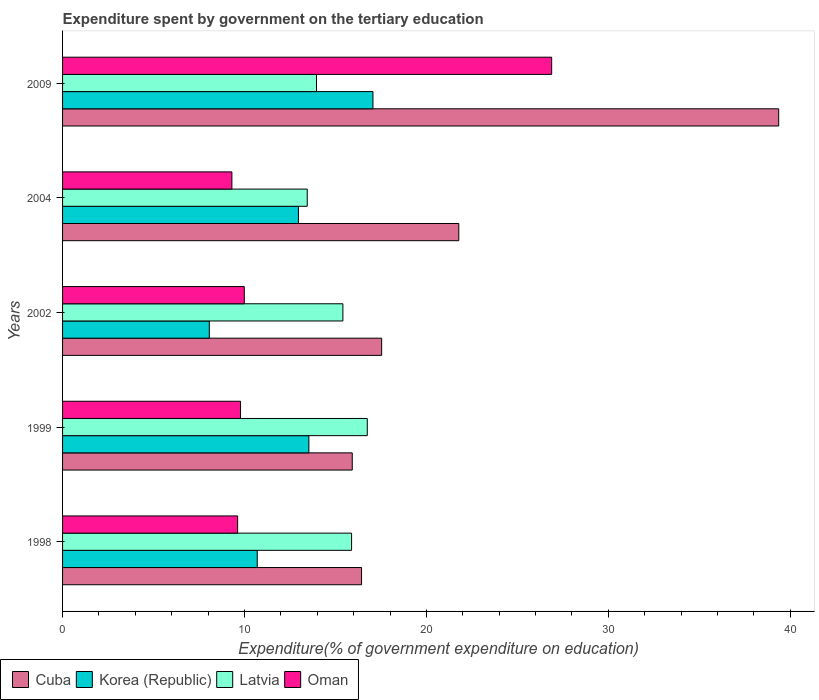How many different coloured bars are there?
Provide a short and direct response. 4. How many bars are there on the 2nd tick from the top?
Give a very brief answer. 4. How many bars are there on the 5th tick from the bottom?
Your answer should be very brief. 4. In how many cases, is the number of bars for a given year not equal to the number of legend labels?
Your response must be concise. 0. What is the expenditure spent by government on the tertiary education in Korea (Republic) in 1998?
Offer a terse response. 10.7. Across all years, what is the maximum expenditure spent by government on the tertiary education in Latvia?
Keep it short and to the point. 16.75. Across all years, what is the minimum expenditure spent by government on the tertiary education in Oman?
Offer a terse response. 9.31. In which year was the expenditure spent by government on the tertiary education in Oman maximum?
Provide a succinct answer. 2009. In which year was the expenditure spent by government on the tertiary education in Latvia minimum?
Give a very brief answer. 2004. What is the total expenditure spent by government on the tertiary education in Korea (Republic) in the graph?
Your answer should be compact. 62.33. What is the difference between the expenditure spent by government on the tertiary education in Latvia in 1998 and that in 2002?
Offer a very short reply. 0.48. What is the difference between the expenditure spent by government on the tertiary education in Oman in 2009 and the expenditure spent by government on the tertiary education in Latvia in 2002?
Ensure brevity in your answer.  11.48. What is the average expenditure spent by government on the tertiary education in Latvia per year?
Make the answer very short. 15.09. In the year 2002, what is the difference between the expenditure spent by government on the tertiary education in Cuba and expenditure spent by government on the tertiary education in Korea (Republic)?
Offer a very short reply. 9.47. What is the ratio of the expenditure spent by government on the tertiary education in Cuba in 1998 to that in 1999?
Provide a short and direct response. 1.03. Is the difference between the expenditure spent by government on the tertiary education in Cuba in 1998 and 2002 greater than the difference between the expenditure spent by government on the tertiary education in Korea (Republic) in 1998 and 2002?
Offer a very short reply. No. What is the difference between the highest and the second highest expenditure spent by government on the tertiary education in Cuba?
Your answer should be compact. 17.58. What is the difference between the highest and the lowest expenditure spent by government on the tertiary education in Korea (Republic)?
Provide a succinct answer. 8.99. Is it the case that in every year, the sum of the expenditure spent by government on the tertiary education in Cuba and expenditure spent by government on the tertiary education in Latvia is greater than the sum of expenditure spent by government on the tertiary education in Oman and expenditure spent by government on the tertiary education in Korea (Republic)?
Make the answer very short. Yes. What does the 4th bar from the top in 2002 represents?
Provide a succinct answer. Cuba. What does the 3rd bar from the bottom in 2002 represents?
Make the answer very short. Latvia. How many bars are there?
Offer a terse response. 20. How many years are there in the graph?
Ensure brevity in your answer.  5. Are the values on the major ticks of X-axis written in scientific E-notation?
Offer a terse response. No. Where does the legend appear in the graph?
Keep it short and to the point. Bottom left. How many legend labels are there?
Keep it short and to the point. 4. How are the legend labels stacked?
Offer a terse response. Horizontal. What is the title of the graph?
Ensure brevity in your answer.  Expenditure spent by government on the tertiary education. Does "Estonia" appear as one of the legend labels in the graph?
Offer a very short reply. No. What is the label or title of the X-axis?
Keep it short and to the point. Expenditure(% of government expenditure on education). What is the label or title of the Y-axis?
Ensure brevity in your answer.  Years. What is the Expenditure(% of government expenditure on education) of Cuba in 1998?
Ensure brevity in your answer.  16.43. What is the Expenditure(% of government expenditure on education) in Korea (Republic) in 1998?
Make the answer very short. 10.7. What is the Expenditure(% of government expenditure on education) in Latvia in 1998?
Your response must be concise. 15.89. What is the Expenditure(% of government expenditure on education) of Oman in 1998?
Your answer should be very brief. 9.62. What is the Expenditure(% of government expenditure on education) of Cuba in 1999?
Your answer should be very brief. 15.92. What is the Expenditure(% of government expenditure on education) of Korea (Republic) in 1999?
Your response must be concise. 13.54. What is the Expenditure(% of government expenditure on education) in Latvia in 1999?
Provide a succinct answer. 16.75. What is the Expenditure(% of government expenditure on education) of Oman in 1999?
Offer a very short reply. 9.78. What is the Expenditure(% of government expenditure on education) of Cuba in 2002?
Your answer should be very brief. 17.54. What is the Expenditure(% of government expenditure on education) of Korea (Republic) in 2002?
Your answer should be very brief. 8.07. What is the Expenditure(% of government expenditure on education) of Latvia in 2002?
Your answer should be compact. 15.41. What is the Expenditure(% of government expenditure on education) in Oman in 2002?
Make the answer very short. 9.99. What is the Expenditure(% of government expenditure on education) of Cuba in 2004?
Offer a very short reply. 21.78. What is the Expenditure(% of government expenditure on education) in Korea (Republic) in 2004?
Your answer should be very brief. 12.96. What is the Expenditure(% of government expenditure on education) in Latvia in 2004?
Provide a short and direct response. 13.45. What is the Expenditure(% of government expenditure on education) of Oman in 2004?
Your answer should be very brief. 9.31. What is the Expenditure(% of government expenditure on education) in Cuba in 2009?
Offer a very short reply. 39.36. What is the Expenditure(% of government expenditure on education) in Korea (Republic) in 2009?
Make the answer very short. 17.06. What is the Expenditure(% of government expenditure on education) of Latvia in 2009?
Give a very brief answer. 13.96. What is the Expenditure(% of government expenditure on education) in Oman in 2009?
Keep it short and to the point. 26.88. Across all years, what is the maximum Expenditure(% of government expenditure on education) of Cuba?
Ensure brevity in your answer.  39.36. Across all years, what is the maximum Expenditure(% of government expenditure on education) in Korea (Republic)?
Provide a succinct answer. 17.06. Across all years, what is the maximum Expenditure(% of government expenditure on education) of Latvia?
Give a very brief answer. 16.75. Across all years, what is the maximum Expenditure(% of government expenditure on education) of Oman?
Make the answer very short. 26.88. Across all years, what is the minimum Expenditure(% of government expenditure on education) of Cuba?
Offer a very short reply. 15.92. Across all years, what is the minimum Expenditure(% of government expenditure on education) of Korea (Republic)?
Make the answer very short. 8.07. Across all years, what is the minimum Expenditure(% of government expenditure on education) in Latvia?
Offer a very short reply. 13.45. Across all years, what is the minimum Expenditure(% of government expenditure on education) of Oman?
Your answer should be compact. 9.31. What is the total Expenditure(% of government expenditure on education) in Cuba in the graph?
Offer a very short reply. 111.03. What is the total Expenditure(% of government expenditure on education) of Korea (Republic) in the graph?
Ensure brevity in your answer.  62.33. What is the total Expenditure(% of government expenditure on education) in Latvia in the graph?
Offer a terse response. 75.45. What is the total Expenditure(% of government expenditure on education) in Oman in the graph?
Offer a terse response. 65.58. What is the difference between the Expenditure(% of government expenditure on education) of Cuba in 1998 and that in 1999?
Offer a terse response. 0.51. What is the difference between the Expenditure(% of government expenditure on education) of Korea (Republic) in 1998 and that in 1999?
Make the answer very short. -2.84. What is the difference between the Expenditure(% of government expenditure on education) of Latvia in 1998 and that in 1999?
Offer a very short reply. -0.86. What is the difference between the Expenditure(% of government expenditure on education) in Oman in 1998 and that in 1999?
Provide a succinct answer. -0.16. What is the difference between the Expenditure(% of government expenditure on education) in Cuba in 1998 and that in 2002?
Provide a short and direct response. -1.1. What is the difference between the Expenditure(% of government expenditure on education) of Korea (Republic) in 1998 and that in 2002?
Ensure brevity in your answer.  2.63. What is the difference between the Expenditure(% of government expenditure on education) of Latvia in 1998 and that in 2002?
Keep it short and to the point. 0.48. What is the difference between the Expenditure(% of government expenditure on education) of Oman in 1998 and that in 2002?
Your answer should be compact. -0.37. What is the difference between the Expenditure(% of government expenditure on education) of Cuba in 1998 and that in 2004?
Offer a terse response. -5.34. What is the difference between the Expenditure(% of government expenditure on education) of Korea (Republic) in 1998 and that in 2004?
Provide a short and direct response. -2.26. What is the difference between the Expenditure(% of government expenditure on education) of Latvia in 1998 and that in 2004?
Offer a terse response. 2.44. What is the difference between the Expenditure(% of government expenditure on education) in Oman in 1998 and that in 2004?
Offer a very short reply. 0.32. What is the difference between the Expenditure(% of government expenditure on education) of Cuba in 1998 and that in 2009?
Keep it short and to the point. -22.93. What is the difference between the Expenditure(% of government expenditure on education) in Korea (Republic) in 1998 and that in 2009?
Your response must be concise. -6.36. What is the difference between the Expenditure(% of government expenditure on education) in Latvia in 1998 and that in 2009?
Your answer should be compact. 1.93. What is the difference between the Expenditure(% of government expenditure on education) of Oman in 1998 and that in 2009?
Offer a very short reply. -17.26. What is the difference between the Expenditure(% of government expenditure on education) of Cuba in 1999 and that in 2002?
Offer a very short reply. -1.62. What is the difference between the Expenditure(% of government expenditure on education) in Korea (Republic) in 1999 and that in 2002?
Your answer should be compact. 5.47. What is the difference between the Expenditure(% of government expenditure on education) in Latvia in 1999 and that in 2002?
Keep it short and to the point. 1.34. What is the difference between the Expenditure(% of government expenditure on education) of Oman in 1999 and that in 2002?
Offer a terse response. -0.21. What is the difference between the Expenditure(% of government expenditure on education) in Cuba in 1999 and that in 2004?
Offer a terse response. -5.86. What is the difference between the Expenditure(% of government expenditure on education) in Korea (Republic) in 1999 and that in 2004?
Provide a succinct answer. 0.57. What is the difference between the Expenditure(% of government expenditure on education) in Latvia in 1999 and that in 2004?
Offer a very short reply. 3.3. What is the difference between the Expenditure(% of government expenditure on education) of Oman in 1999 and that in 2004?
Provide a succinct answer. 0.48. What is the difference between the Expenditure(% of government expenditure on education) in Cuba in 1999 and that in 2009?
Ensure brevity in your answer.  -23.44. What is the difference between the Expenditure(% of government expenditure on education) of Korea (Republic) in 1999 and that in 2009?
Ensure brevity in your answer.  -3.52. What is the difference between the Expenditure(% of government expenditure on education) in Latvia in 1999 and that in 2009?
Offer a terse response. 2.79. What is the difference between the Expenditure(% of government expenditure on education) of Oman in 1999 and that in 2009?
Give a very brief answer. -17.1. What is the difference between the Expenditure(% of government expenditure on education) of Cuba in 2002 and that in 2004?
Make the answer very short. -4.24. What is the difference between the Expenditure(% of government expenditure on education) in Korea (Republic) in 2002 and that in 2004?
Provide a succinct answer. -4.9. What is the difference between the Expenditure(% of government expenditure on education) in Latvia in 2002 and that in 2004?
Provide a succinct answer. 1.96. What is the difference between the Expenditure(% of government expenditure on education) of Oman in 2002 and that in 2004?
Provide a short and direct response. 0.68. What is the difference between the Expenditure(% of government expenditure on education) of Cuba in 2002 and that in 2009?
Give a very brief answer. -21.82. What is the difference between the Expenditure(% of government expenditure on education) of Korea (Republic) in 2002 and that in 2009?
Offer a very short reply. -8.99. What is the difference between the Expenditure(% of government expenditure on education) in Latvia in 2002 and that in 2009?
Your response must be concise. 1.45. What is the difference between the Expenditure(% of government expenditure on education) of Oman in 2002 and that in 2009?
Your answer should be very brief. -16.89. What is the difference between the Expenditure(% of government expenditure on education) in Cuba in 2004 and that in 2009?
Your answer should be compact. -17.58. What is the difference between the Expenditure(% of government expenditure on education) of Korea (Republic) in 2004 and that in 2009?
Your response must be concise. -4.1. What is the difference between the Expenditure(% of government expenditure on education) in Latvia in 2004 and that in 2009?
Your answer should be compact. -0.51. What is the difference between the Expenditure(% of government expenditure on education) of Oman in 2004 and that in 2009?
Give a very brief answer. -17.58. What is the difference between the Expenditure(% of government expenditure on education) in Cuba in 1998 and the Expenditure(% of government expenditure on education) in Korea (Republic) in 1999?
Keep it short and to the point. 2.9. What is the difference between the Expenditure(% of government expenditure on education) in Cuba in 1998 and the Expenditure(% of government expenditure on education) in Latvia in 1999?
Provide a short and direct response. -0.31. What is the difference between the Expenditure(% of government expenditure on education) of Cuba in 1998 and the Expenditure(% of government expenditure on education) of Oman in 1999?
Offer a terse response. 6.65. What is the difference between the Expenditure(% of government expenditure on education) of Korea (Republic) in 1998 and the Expenditure(% of government expenditure on education) of Latvia in 1999?
Ensure brevity in your answer.  -6.05. What is the difference between the Expenditure(% of government expenditure on education) in Korea (Republic) in 1998 and the Expenditure(% of government expenditure on education) in Oman in 1999?
Provide a succinct answer. 0.92. What is the difference between the Expenditure(% of government expenditure on education) in Latvia in 1998 and the Expenditure(% of government expenditure on education) in Oman in 1999?
Give a very brief answer. 6.1. What is the difference between the Expenditure(% of government expenditure on education) in Cuba in 1998 and the Expenditure(% of government expenditure on education) in Korea (Republic) in 2002?
Your answer should be very brief. 8.37. What is the difference between the Expenditure(% of government expenditure on education) in Cuba in 1998 and the Expenditure(% of government expenditure on education) in Latvia in 2002?
Your answer should be very brief. 1.03. What is the difference between the Expenditure(% of government expenditure on education) of Cuba in 1998 and the Expenditure(% of government expenditure on education) of Oman in 2002?
Provide a short and direct response. 6.45. What is the difference between the Expenditure(% of government expenditure on education) in Korea (Republic) in 1998 and the Expenditure(% of government expenditure on education) in Latvia in 2002?
Your answer should be compact. -4.71. What is the difference between the Expenditure(% of government expenditure on education) of Korea (Republic) in 1998 and the Expenditure(% of government expenditure on education) of Oman in 2002?
Provide a short and direct response. 0.71. What is the difference between the Expenditure(% of government expenditure on education) in Latvia in 1998 and the Expenditure(% of government expenditure on education) in Oman in 2002?
Keep it short and to the point. 5.9. What is the difference between the Expenditure(% of government expenditure on education) in Cuba in 1998 and the Expenditure(% of government expenditure on education) in Korea (Republic) in 2004?
Make the answer very short. 3.47. What is the difference between the Expenditure(% of government expenditure on education) of Cuba in 1998 and the Expenditure(% of government expenditure on education) of Latvia in 2004?
Offer a terse response. 2.99. What is the difference between the Expenditure(% of government expenditure on education) in Cuba in 1998 and the Expenditure(% of government expenditure on education) in Oman in 2004?
Provide a succinct answer. 7.13. What is the difference between the Expenditure(% of government expenditure on education) in Korea (Republic) in 1998 and the Expenditure(% of government expenditure on education) in Latvia in 2004?
Give a very brief answer. -2.75. What is the difference between the Expenditure(% of government expenditure on education) in Korea (Republic) in 1998 and the Expenditure(% of government expenditure on education) in Oman in 2004?
Offer a terse response. 1.39. What is the difference between the Expenditure(% of government expenditure on education) in Latvia in 1998 and the Expenditure(% of government expenditure on education) in Oman in 2004?
Ensure brevity in your answer.  6.58. What is the difference between the Expenditure(% of government expenditure on education) of Cuba in 1998 and the Expenditure(% of government expenditure on education) of Korea (Republic) in 2009?
Keep it short and to the point. -0.63. What is the difference between the Expenditure(% of government expenditure on education) in Cuba in 1998 and the Expenditure(% of government expenditure on education) in Latvia in 2009?
Provide a succinct answer. 2.48. What is the difference between the Expenditure(% of government expenditure on education) of Cuba in 1998 and the Expenditure(% of government expenditure on education) of Oman in 2009?
Your answer should be compact. -10.45. What is the difference between the Expenditure(% of government expenditure on education) of Korea (Republic) in 1998 and the Expenditure(% of government expenditure on education) of Latvia in 2009?
Ensure brevity in your answer.  -3.26. What is the difference between the Expenditure(% of government expenditure on education) of Korea (Republic) in 1998 and the Expenditure(% of government expenditure on education) of Oman in 2009?
Give a very brief answer. -16.18. What is the difference between the Expenditure(% of government expenditure on education) in Latvia in 1998 and the Expenditure(% of government expenditure on education) in Oman in 2009?
Offer a very short reply. -11. What is the difference between the Expenditure(% of government expenditure on education) in Cuba in 1999 and the Expenditure(% of government expenditure on education) in Korea (Republic) in 2002?
Make the answer very short. 7.86. What is the difference between the Expenditure(% of government expenditure on education) in Cuba in 1999 and the Expenditure(% of government expenditure on education) in Latvia in 2002?
Ensure brevity in your answer.  0.51. What is the difference between the Expenditure(% of government expenditure on education) of Cuba in 1999 and the Expenditure(% of government expenditure on education) of Oman in 2002?
Provide a succinct answer. 5.93. What is the difference between the Expenditure(% of government expenditure on education) of Korea (Republic) in 1999 and the Expenditure(% of government expenditure on education) of Latvia in 2002?
Make the answer very short. -1.87. What is the difference between the Expenditure(% of government expenditure on education) of Korea (Republic) in 1999 and the Expenditure(% of government expenditure on education) of Oman in 2002?
Your response must be concise. 3.55. What is the difference between the Expenditure(% of government expenditure on education) of Latvia in 1999 and the Expenditure(% of government expenditure on education) of Oman in 2002?
Your answer should be compact. 6.76. What is the difference between the Expenditure(% of government expenditure on education) of Cuba in 1999 and the Expenditure(% of government expenditure on education) of Korea (Republic) in 2004?
Give a very brief answer. 2.96. What is the difference between the Expenditure(% of government expenditure on education) in Cuba in 1999 and the Expenditure(% of government expenditure on education) in Latvia in 2004?
Offer a very short reply. 2.47. What is the difference between the Expenditure(% of government expenditure on education) in Cuba in 1999 and the Expenditure(% of government expenditure on education) in Oman in 2004?
Offer a terse response. 6.62. What is the difference between the Expenditure(% of government expenditure on education) in Korea (Republic) in 1999 and the Expenditure(% of government expenditure on education) in Latvia in 2004?
Make the answer very short. 0.09. What is the difference between the Expenditure(% of government expenditure on education) of Korea (Republic) in 1999 and the Expenditure(% of government expenditure on education) of Oman in 2004?
Offer a very short reply. 4.23. What is the difference between the Expenditure(% of government expenditure on education) of Latvia in 1999 and the Expenditure(% of government expenditure on education) of Oman in 2004?
Ensure brevity in your answer.  7.44. What is the difference between the Expenditure(% of government expenditure on education) of Cuba in 1999 and the Expenditure(% of government expenditure on education) of Korea (Republic) in 2009?
Offer a very short reply. -1.14. What is the difference between the Expenditure(% of government expenditure on education) in Cuba in 1999 and the Expenditure(% of government expenditure on education) in Latvia in 2009?
Make the answer very short. 1.96. What is the difference between the Expenditure(% of government expenditure on education) of Cuba in 1999 and the Expenditure(% of government expenditure on education) of Oman in 2009?
Your answer should be very brief. -10.96. What is the difference between the Expenditure(% of government expenditure on education) in Korea (Republic) in 1999 and the Expenditure(% of government expenditure on education) in Latvia in 2009?
Make the answer very short. -0.42. What is the difference between the Expenditure(% of government expenditure on education) in Korea (Republic) in 1999 and the Expenditure(% of government expenditure on education) in Oman in 2009?
Ensure brevity in your answer.  -13.34. What is the difference between the Expenditure(% of government expenditure on education) of Latvia in 1999 and the Expenditure(% of government expenditure on education) of Oman in 2009?
Ensure brevity in your answer.  -10.13. What is the difference between the Expenditure(% of government expenditure on education) in Cuba in 2002 and the Expenditure(% of government expenditure on education) in Korea (Republic) in 2004?
Your response must be concise. 4.57. What is the difference between the Expenditure(% of government expenditure on education) in Cuba in 2002 and the Expenditure(% of government expenditure on education) in Latvia in 2004?
Ensure brevity in your answer.  4.09. What is the difference between the Expenditure(% of government expenditure on education) in Cuba in 2002 and the Expenditure(% of government expenditure on education) in Oman in 2004?
Offer a terse response. 8.23. What is the difference between the Expenditure(% of government expenditure on education) in Korea (Republic) in 2002 and the Expenditure(% of government expenditure on education) in Latvia in 2004?
Ensure brevity in your answer.  -5.38. What is the difference between the Expenditure(% of government expenditure on education) in Korea (Republic) in 2002 and the Expenditure(% of government expenditure on education) in Oman in 2004?
Keep it short and to the point. -1.24. What is the difference between the Expenditure(% of government expenditure on education) of Latvia in 2002 and the Expenditure(% of government expenditure on education) of Oman in 2004?
Your answer should be very brief. 6.1. What is the difference between the Expenditure(% of government expenditure on education) in Cuba in 2002 and the Expenditure(% of government expenditure on education) in Korea (Republic) in 2009?
Provide a short and direct response. 0.48. What is the difference between the Expenditure(% of government expenditure on education) of Cuba in 2002 and the Expenditure(% of government expenditure on education) of Latvia in 2009?
Offer a terse response. 3.58. What is the difference between the Expenditure(% of government expenditure on education) in Cuba in 2002 and the Expenditure(% of government expenditure on education) in Oman in 2009?
Offer a terse response. -9.34. What is the difference between the Expenditure(% of government expenditure on education) of Korea (Republic) in 2002 and the Expenditure(% of government expenditure on education) of Latvia in 2009?
Your answer should be compact. -5.89. What is the difference between the Expenditure(% of government expenditure on education) in Korea (Republic) in 2002 and the Expenditure(% of government expenditure on education) in Oman in 2009?
Your answer should be compact. -18.82. What is the difference between the Expenditure(% of government expenditure on education) of Latvia in 2002 and the Expenditure(% of government expenditure on education) of Oman in 2009?
Offer a very short reply. -11.48. What is the difference between the Expenditure(% of government expenditure on education) of Cuba in 2004 and the Expenditure(% of government expenditure on education) of Korea (Republic) in 2009?
Your answer should be very brief. 4.72. What is the difference between the Expenditure(% of government expenditure on education) in Cuba in 2004 and the Expenditure(% of government expenditure on education) in Latvia in 2009?
Give a very brief answer. 7.82. What is the difference between the Expenditure(% of government expenditure on education) in Cuba in 2004 and the Expenditure(% of government expenditure on education) in Oman in 2009?
Give a very brief answer. -5.1. What is the difference between the Expenditure(% of government expenditure on education) in Korea (Republic) in 2004 and the Expenditure(% of government expenditure on education) in Latvia in 2009?
Offer a very short reply. -0.99. What is the difference between the Expenditure(% of government expenditure on education) of Korea (Republic) in 2004 and the Expenditure(% of government expenditure on education) of Oman in 2009?
Provide a short and direct response. -13.92. What is the difference between the Expenditure(% of government expenditure on education) of Latvia in 2004 and the Expenditure(% of government expenditure on education) of Oman in 2009?
Make the answer very short. -13.44. What is the average Expenditure(% of government expenditure on education) in Cuba per year?
Keep it short and to the point. 22.21. What is the average Expenditure(% of government expenditure on education) of Korea (Republic) per year?
Your answer should be compact. 12.47. What is the average Expenditure(% of government expenditure on education) of Latvia per year?
Provide a short and direct response. 15.09. What is the average Expenditure(% of government expenditure on education) of Oman per year?
Keep it short and to the point. 13.12. In the year 1998, what is the difference between the Expenditure(% of government expenditure on education) of Cuba and Expenditure(% of government expenditure on education) of Korea (Republic)?
Your answer should be very brief. 5.73. In the year 1998, what is the difference between the Expenditure(% of government expenditure on education) in Cuba and Expenditure(% of government expenditure on education) in Latvia?
Give a very brief answer. 0.55. In the year 1998, what is the difference between the Expenditure(% of government expenditure on education) of Cuba and Expenditure(% of government expenditure on education) of Oman?
Your answer should be compact. 6.81. In the year 1998, what is the difference between the Expenditure(% of government expenditure on education) in Korea (Republic) and Expenditure(% of government expenditure on education) in Latvia?
Ensure brevity in your answer.  -5.19. In the year 1998, what is the difference between the Expenditure(% of government expenditure on education) in Korea (Republic) and Expenditure(% of government expenditure on education) in Oman?
Provide a succinct answer. 1.08. In the year 1998, what is the difference between the Expenditure(% of government expenditure on education) of Latvia and Expenditure(% of government expenditure on education) of Oman?
Offer a terse response. 6.26. In the year 1999, what is the difference between the Expenditure(% of government expenditure on education) of Cuba and Expenditure(% of government expenditure on education) of Korea (Republic)?
Provide a succinct answer. 2.38. In the year 1999, what is the difference between the Expenditure(% of government expenditure on education) in Cuba and Expenditure(% of government expenditure on education) in Latvia?
Provide a succinct answer. -0.83. In the year 1999, what is the difference between the Expenditure(% of government expenditure on education) of Cuba and Expenditure(% of government expenditure on education) of Oman?
Make the answer very short. 6.14. In the year 1999, what is the difference between the Expenditure(% of government expenditure on education) of Korea (Republic) and Expenditure(% of government expenditure on education) of Latvia?
Your answer should be compact. -3.21. In the year 1999, what is the difference between the Expenditure(% of government expenditure on education) of Korea (Republic) and Expenditure(% of government expenditure on education) of Oman?
Your answer should be compact. 3.76. In the year 1999, what is the difference between the Expenditure(% of government expenditure on education) of Latvia and Expenditure(% of government expenditure on education) of Oman?
Make the answer very short. 6.97. In the year 2002, what is the difference between the Expenditure(% of government expenditure on education) in Cuba and Expenditure(% of government expenditure on education) in Korea (Republic)?
Keep it short and to the point. 9.47. In the year 2002, what is the difference between the Expenditure(% of government expenditure on education) of Cuba and Expenditure(% of government expenditure on education) of Latvia?
Keep it short and to the point. 2.13. In the year 2002, what is the difference between the Expenditure(% of government expenditure on education) in Cuba and Expenditure(% of government expenditure on education) in Oman?
Provide a short and direct response. 7.55. In the year 2002, what is the difference between the Expenditure(% of government expenditure on education) in Korea (Republic) and Expenditure(% of government expenditure on education) in Latvia?
Your answer should be compact. -7.34. In the year 2002, what is the difference between the Expenditure(% of government expenditure on education) of Korea (Republic) and Expenditure(% of government expenditure on education) of Oman?
Your answer should be very brief. -1.92. In the year 2002, what is the difference between the Expenditure(% of government expenditure on education) in Latvia and Expenditure(% of government expenditure on education) in Oman?
Give a very brief answer. 5.42. In the year 2004, what is the difference between the Expenditure(% of government expenditure on education) in Cuba and Expenditure(% of government expenditure on education) in Korea (Republic)?
Provide a short and direct response. 8.81. In the year 2004, what is the difference between the Expenditure(% of government expenditure on education) in Cuba and Expenditure(% of government expenditure on education) in Latvia?
Make the answer very short. 8.33. In the year 2004, what is the difference between the Expenditure(% of government expenditure on education) in Cuba and Expenditure(% of government expenditure on education) in Oman?
Ensure brevity in your answer.  12.47. In the year 2004, what is the difference between the Expenditure(% of government expenditure on education) in Korea (Republic) and Expenditure(% of government expenditure on education) in Latvia?
Make the answer very short. -0.48. In the year 2004, what is the difference between the Expenditure(% of government expenditure on education) of Korea (Republic) and Expenditure(% of government expenditure on education) of Oman?
Provide a succinct answer. 3.66. In the year 2004, what is the difference between the Expenditure(% of government expenditure on education) of Latvia and Expenditure(% of government expenditure on education) of Oman?
Keep it short and to the point. 4.14. In the year 2009, what is the difference between the Expenditure(% of government expenditure on education) in Cuba and Expenditure(% of government expenditure on education) in Korea (Republic)?
Offer a terse response. 22.3. In the year 2009, what is the difference between the Expenditure(% of government expenditure on education) of Cuba and Expenditure(% of government expenditure on education) of Latvia?
Keep it short and to the point. 25.4. In the year 2009, what is the difference between the Expenditure(% of government expenditure on education) in Cuba and Expenditure(% of government expenditure on education) in Oman?
Offer a terse response. 12.48. In the year 2009, what is the difference between the Expenditure(% of government expenditure on education) of Korea (Republic) and Expenditure(% of government expenditure on education) of Latvia?
Your answer should be very brief. 3.1. In the year 2009, what is the difference between the Expenditure(% of government expenditure on education) of Korea (Republic) and Expenditure(% of government expenditure on education) of Oman?
Your answer should be very brief. -9.82. In the year 2009, what is the difference between the Expenditure(% of government expenditure on education) of Latvia and Expenditure(% of government expenditure on education) of Oman?
Your response must be concise. -12.93. What is the ratio of the Expenditure(% of government expenditure on education) in Cuba in 1998 to that in 1999?
Give a very brief answer. 1.03. What is the ratio of the Expenditure(% of government expenditure on education) of Korea (Republic) in 1998 to that in 1999?
Give a very brief answer. 0.79. What is the ratio of the Expenditure(% of government expenditure on education) of Latvia in 1998 to that in 1999?
Give a very brief answer. 0.95. What is the ratio of the Expenditure(% of government expenditure on education) in Oman in 1998 to that in 1999?
Your answer should be compact. 0.98. What is the ratio of the Expenditure(% of government expenditure on education) in Cuba in 1998 to that in 2002?
Make the answer very short. 0.94. What is the ratio of the Expenditure(% of government expenditure on education) of Korea (Republic) in 1998 to that in 2002?
Your answer should be compact. 1.33. What is the ratio of the Expenditure(% of government expenditure on education) of Latvia in 1998 to that in 2002?
Your answer should be very brief. 1.03. What is the ratio of the Expenditure(% of government expenditure on education) of Oman in 1998 to that in 2002?
Offer a terse response. 0.96. What is the ratio of the Expenditure(% of government expenditure on education) of Cuba in 1998 to that in 2004?
Keep it short and to the point. 0.75. What is the ratio of the Expenditure(% of government expenditure on education) in Korea (Republic) in 1998 to that in 2004?
Ensure brevity in your answer.  0.83. What is the ratio of the Expenditure(% of government expenditure on education) in Latvia in 1998 to that in 2004?
Give a very brief answer. 1.18. What is the ratio of the Expenditure(% of government expenditure on education) in Oman in 1998 to that in 2004?
Offer a terse response. 1.03. What is the ratio of the Expenditure(% of government expenditure on education) in Cuba in 1998 to that in 2009?
Make the answer very short. 0.42. What is the ratio of the Expenditure(% of government expenditure on education) of Korea (Republic) in 1998 to that in 2009?
Ensure brevity in your answer.  0.63. What is the ratio of the Expenditure(% of government expenditure on education) of Latvia in 1998 to that in 2009?
Make the answer very short. 1.14. What is the ratio of the Expenditure(% of government expenditure on education) in Oman in 1998 to that in 2009?
Offer a very short reply. 0.36. What is the ratio of the Expenditure(% of government expenditure on education) of Cuba in 1999 to that in 2002?
Offer a terse response. 0.91. What is the ratio of the Expenditure(% of government expenditure on education) of Korea (Republic) in 1999 to that in 2002?
Your answer should be very brief. 1.68. What is the ratio of the Expenditure(% of government expenditure on education) in Latvia in 1999 to that in 2002?
Ensure brevity in your answer.  1.09. What is the ratio of the Expenditure(% of government expenditure on education) of Oman in 1999 to that in 2002?
Your answer should be very brief. 0.98. What is the ratio of the Expenditure(% of government expenditure on education) of Cuba in 1999 to that in 2004?
Keep it short and to the point. 0.73. What is the ratio of the Expenditure(% of government expenditure on education) of Korea (Republic) in 1999 to that in 2004?
Keep it short and to the point. 1.04. What is the ratio of the Expenditure(% of government expenditure on education) in Latvia in 1999 to that in 2004?
Your answer should be very brief. 1.25. What is the ratio of the Expenditure(% of government expenditure on education) of Oman in 1999 to that in 2004?
Provide a short and direct response. 1.05. What is the ratio of the Expenditure(% of government expenditure on education) of Cuba in 1999 to that in 2009?
Provide a succinct answer. 0.4. What is the ratio of the Expenditure(% of government expenditure on education) in Korea (Republic) in 1999 to that in 2009?
Your response must be concise. 0.79. What is the ratio of the Expenditure(% of government expenditure on education) of Latvia in 1999 to that in 2009?
Make the answer very short. 1.2. What is the ratio of the Expenditure(% of government expenditure on education) of Oman in 1999 to that in 2009?
Keep it short and to the point. 0.36. What is the ratio of the Expenditure(% of government expenditure on education) in Cuba in 2002 to that in 2004?
Your response must be concise. 0.81. What is the ratio of the Expenditure(% of government expenditure on education) of Korea (Republic) in 2002 to that in 2004?
Provide a short and direct response. 0.62. What is the ratio of the Expenditure(% of government expenditure on education) of Latvia in 2002 to that in 2004?
Your answer should be compact. 1.15. What is the ratio of the Expenditure(% of government expenditure on education) in Oman in 2002 to that in 2004?
Provide a short and direct response. 1.07. What is the ratio of the Expenditure(% of government expenditure on education) of Cuba in 2002 to that in 2009?
Provide a succinct answer. 0.45. What is the ratio of the Expenditure(% of government expenditure on education) in Korea (Republic) in 2002 to that in 2009?
Your response must be concise. 0.47. What is the ratio of the Expenditure(% of government expenditure on education) of Latvia in 2002 to that in 2009?
Your answer should be very brief. 1.1. What is the ratio of the Expenditure(% of government expenditure on education) in Oman in 2002 to that in 2009?
Make the answer very short. 0.37. What is the ratio of the Expenditure(% of government expenditure on education) in Cuba in 2004 to that in 2009?
Provide a succinct answer. 0.55. What is the ratio of the Expenditure(% of government expenditure on education) of Korea (Republic) in 2004 to that in 2009?
Provide a short and direct response. 0.76. What is the ratio of the Expenditure(% of government expenditure on education) in Latvia in 2004 to that in 2009?
Ensure brevity in your answer.  0.96. What is the ratio of the Expenditure(% of government expenditure on education) of Oman in 2004 to that in 2009?
Offer a terse response. 0.35. What is the difference between the highest and the second highest Expenditure(% of government expenditure on education) of Cuba?
Offer a terse response. 17.58. What is the difference between the highest and the second highest Expenditure(% of government expenditure on education) in Korea (Republic)?
Ensure brevity in your answer.  3.52. What is the difference between the highest and the second highest Expenditure(% of government expenditure on education) of Latvia?
Keep it short and to the point. 0.86. What is the difference between the highest and the second highest Expenditure(% of government expenditure on education) in Oman?
Provide a succinct answer. 16.89. What is the difference between the highest and the lowest Expenditure(% of government expenditure on education) of Cuba?
Ensure brevity in your answer.  23.44. What is the difference between the highest and the lowest Expenditure(% of government expenditure on education) in Korea (Republic)?
Give a very brief answer. 8.99. What is the difference between the highest and the lowest Expenditure(% of government expenditure on education) of Latvia?
Your answer should be compact. 3.3. What is the difference between the highest and the lowest Expenditure(% of government expenditure on education) of Oman?
Your answer should be very brief. 17.58. 